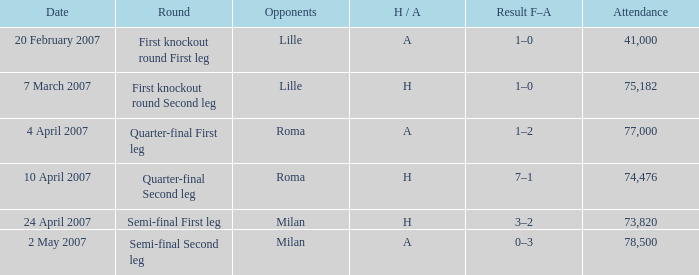Which round has Attendance larger than 41,000, a H/A of A, and a Result F–A of 1–2? Quarter-final First leg. 